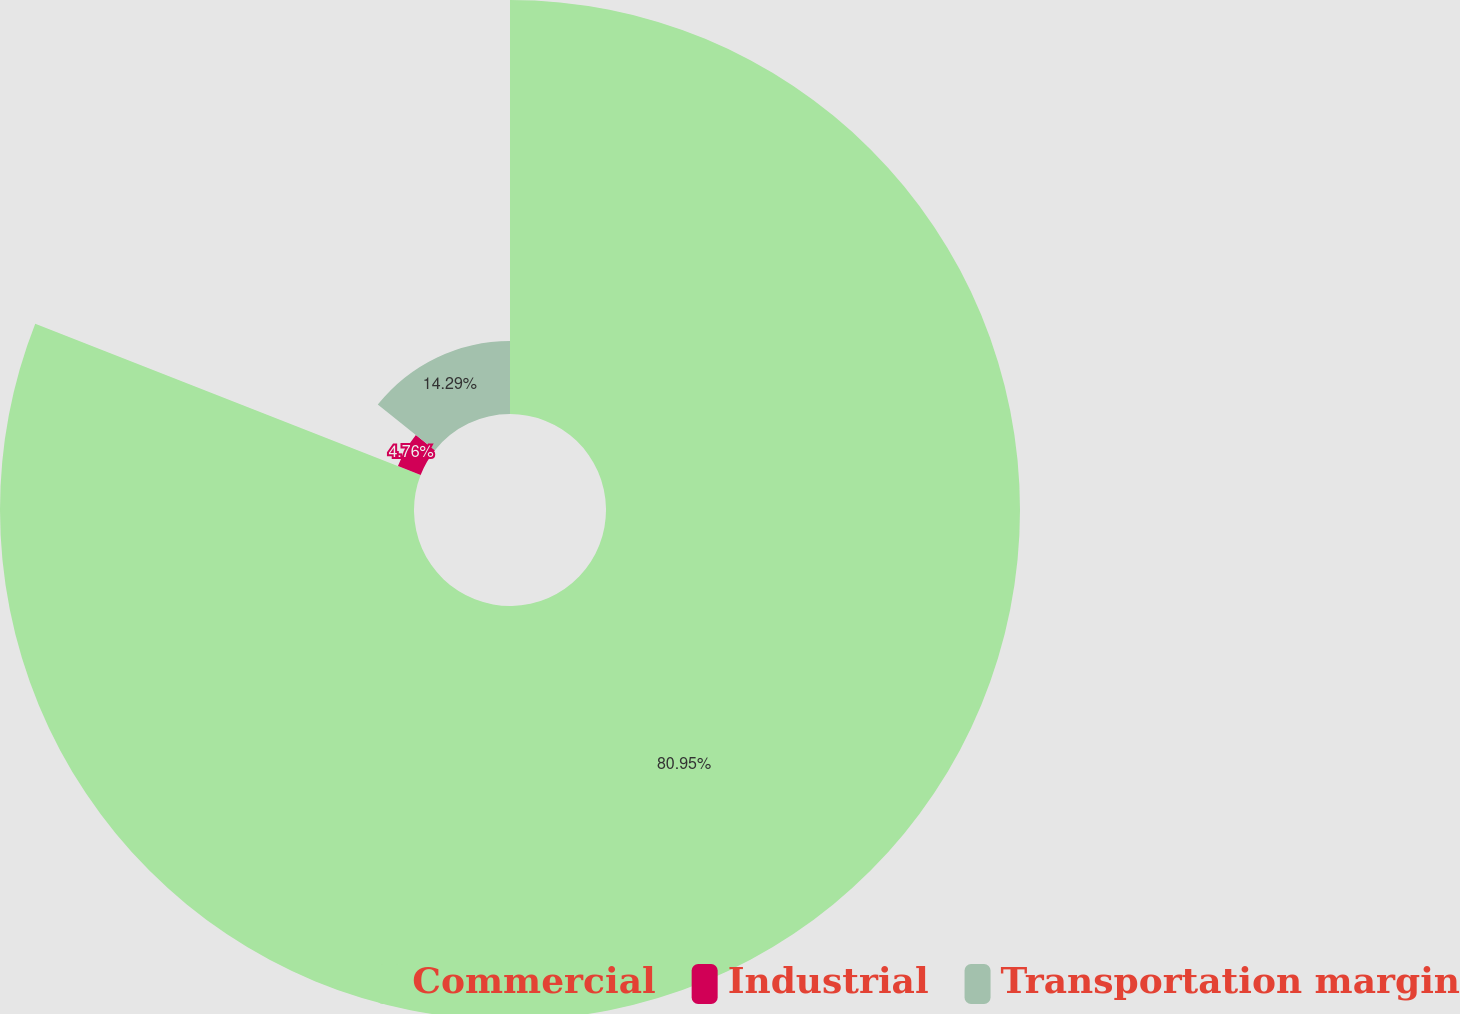Convert chart. <chart><loc_0><loc_0><loc_500><loc_500><pie_chart><fcel>Commercial<fcel>Industrial<fcel>Transportation margin<nl><fcel>80.95%<fcel>4.76%<fcel>14.29%<nl></chart> 